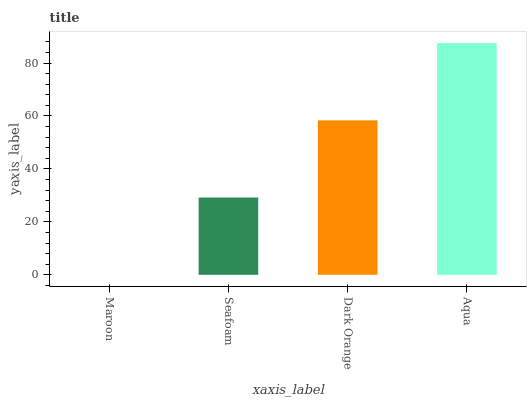Is Maroon the minimum?
Answer yes or no. Yes. Is Aqua the maximum?
Answer yes or no. Yes. Is Seafoam the minimum?
Answer yes or no. No. Is Seafoam the maximum?
Answer yes or no. No. Is Seafoam greater than Maroon?
Answer yes or no. Yes. Is Maroon less than Seafoam?
Answer yes or no. Yes. Is Maroon greater than Seafoam?
Answer yes or no. No. Is Seafoam less than Maroon?
Answer yes or no. No. Is Dark Orange the high median?
Answer yes or no. Yes. Is Seafoam the low median?
Answer yes or no. Yes. Is Maroon the high median?
Answer yes or no. No. Is Dark Orange the low median?
Answer yes or no. No. 